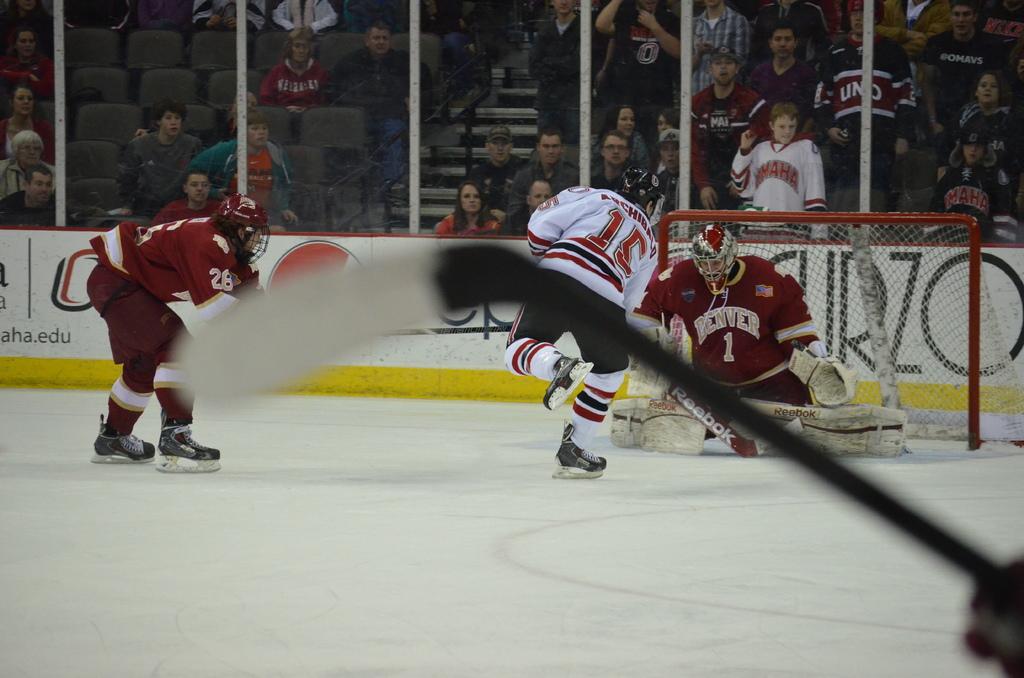What team does the goaltender play on?
Ensure brevity in your answer.  Denver. What number is on the jersey of the goaltender?
Provide a short and direct response. 1. 